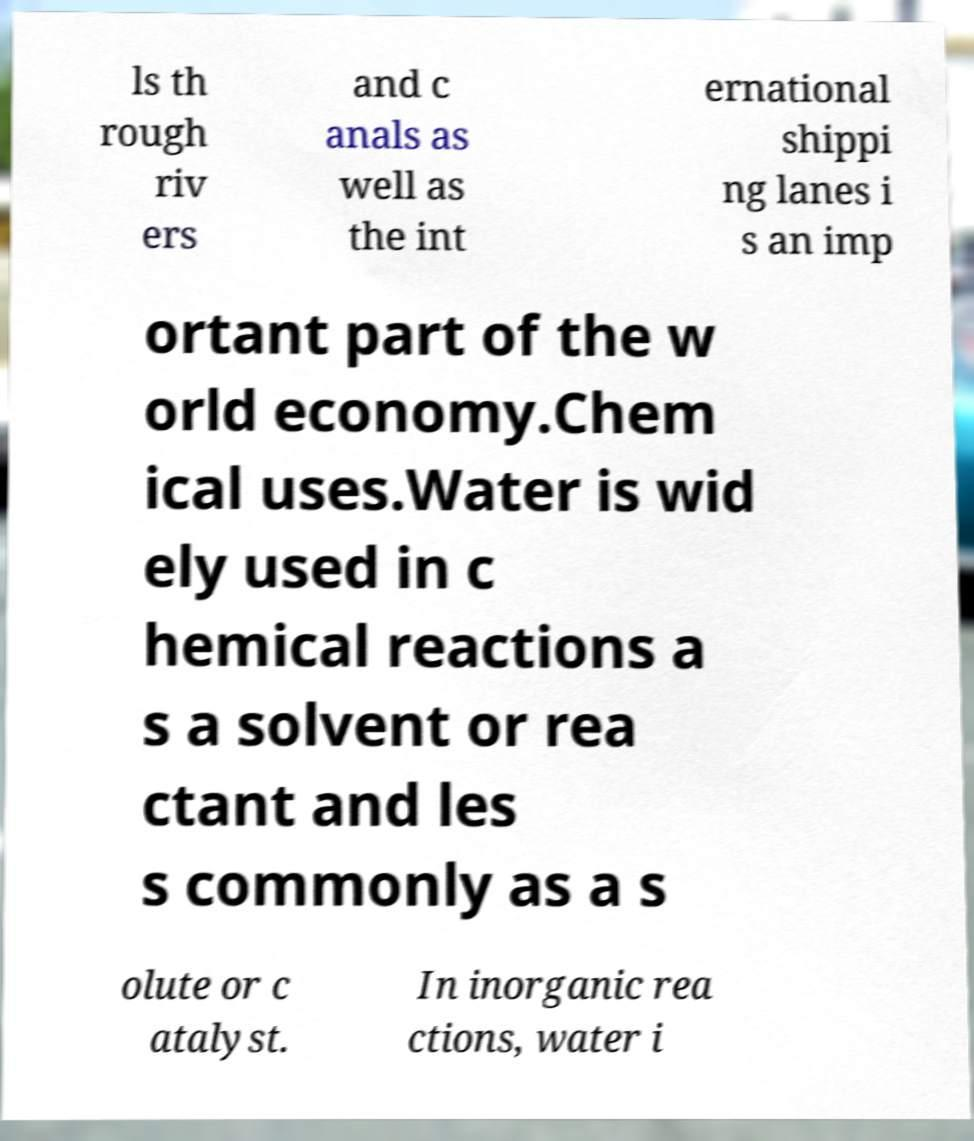Could you extract and type out the text from this image? ls th rough riv ers and c anals as well as the int ernational shippi ng lanes i s an imp ortant part of the w orld economy.Chem ical uses.Water is wid ely used in c hemical reactions a s a solvent or rea ctant and les s commonly as a s olute or c atalyst. In inorganic rea ctions, water i 